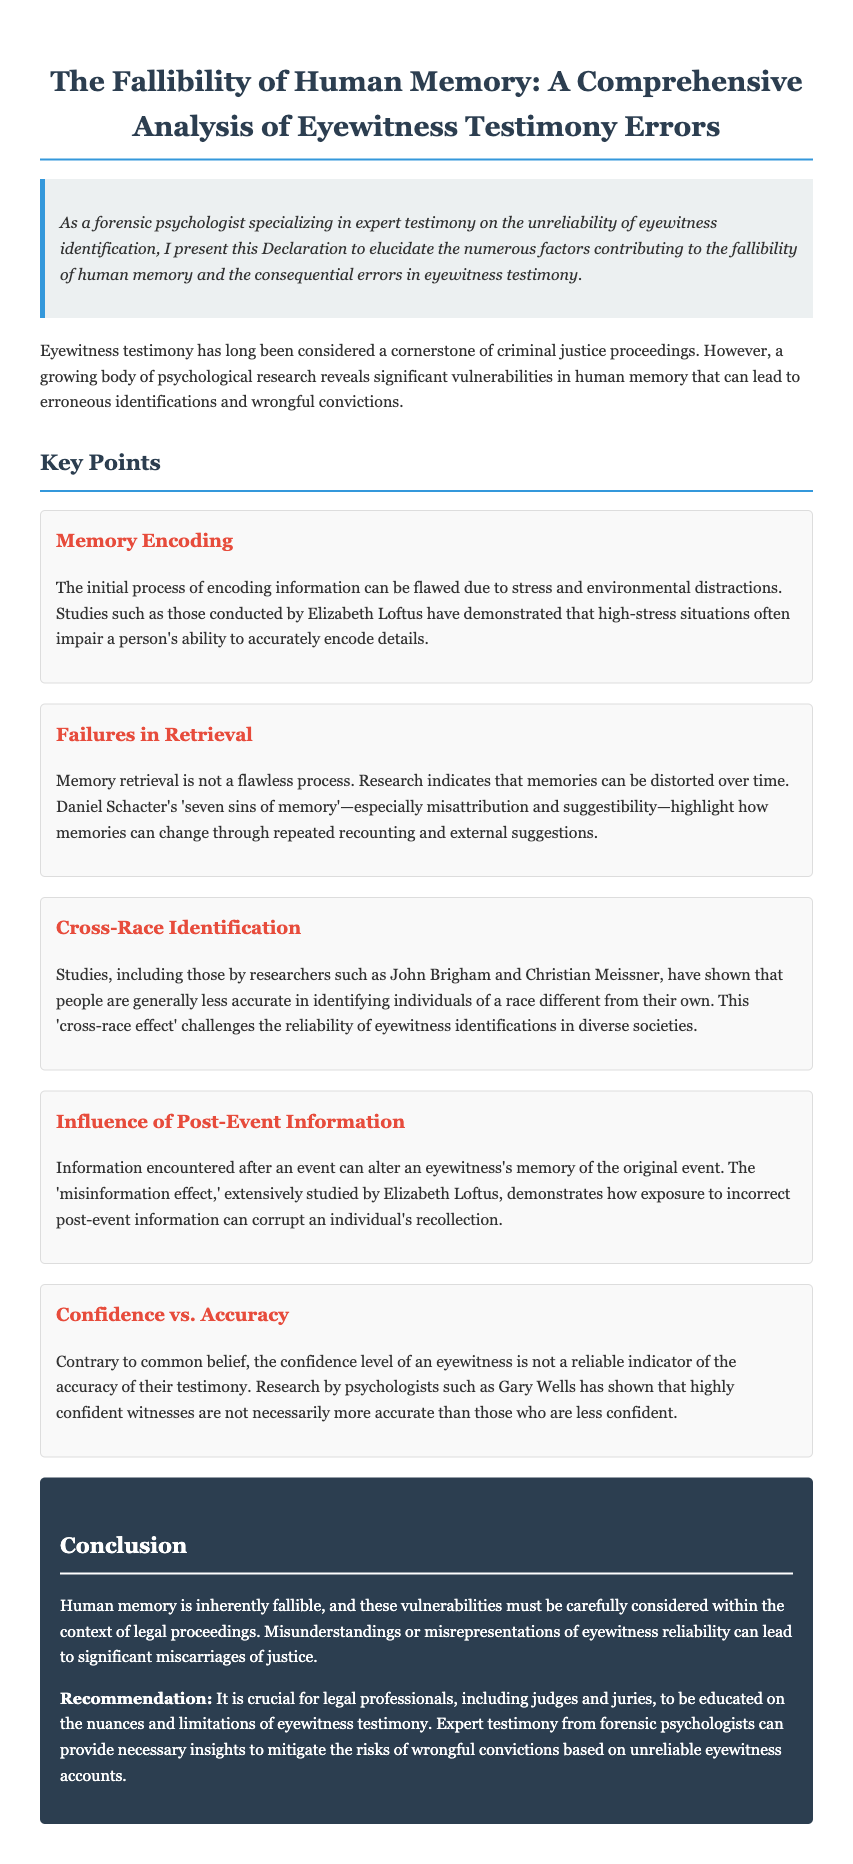What is the title of the document? The title of the document is stated at the top of the text.
Answer: The Fallibility of Human Memory: A Comprehensive Analysis of Eyewitness Testimony Errors Who conducted studies demonstrating the flaws in memory encoding? Elizabeth Loftus is mentioned as a researcher who has conducted studies in this area within the document.
Answer: Elizabeth Loftus What is the 'cross-race effect'? The document describes this effect as the phenomenon where people are generally less accurate in identifying individuals of a different race.
Answer: People are generally less accurate in identifying individuals of a different race What are Daniel Schacter's 'seven sins of memory'? The document notes these sins, particularly mentioning misattribution and suggestibility as relevant to memory retrieval errors.
Answer: Misattribution and suggestibility What does the 'misinformation effect' refer to? This effect, studied by Elizabeth Loftus, indicates how post-event information can alter an eyewitness's memory of the original event.
Answer: Post-event information can alter an eyewitness's memory of the original event What should legal professionals be educated on? The document specifies that it is crucial for legal professionals to understand the nuances and limitations of eyewitness testimony.
Answer: The nuances and limitations of eyewitness testimony 